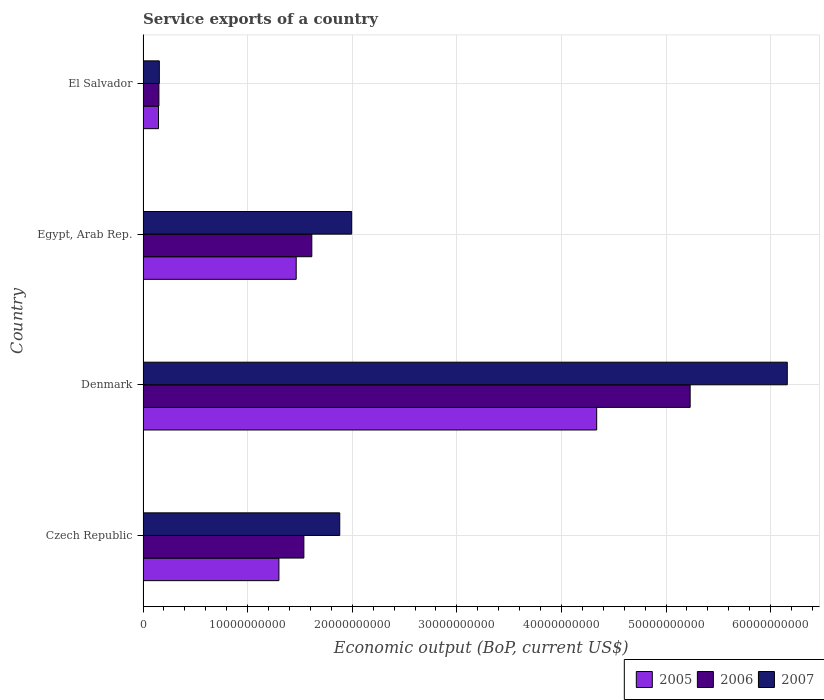How many bars are there on the 4th tick from the top?
Ensure brevity in your answer.  3. What is the label of the 2nd group of bars from the top?
Give a very brief answer. Egypt, Arab Rep. What is the service exports in 2005 in Denmark?
Offer a terse response. 4.34e+1. Across all countries, what is the maximum service exports in 2006?
Provide a short and direct response. 5.23e+1. Across all countries, what is the minimum service exports in 2006?
Provide a succinct answer. 1.52e+09. In which country was the service exports in 2005 minimum?
Your response must be concise. El Salvador. What is the total service exports in 2006 in the graph?
Your answer should be very brief. 8.53e+1. What is the difference between the service exports in 2006 in Denmark and that in Egypt, Arab Rep.?
Keep it short and to the point. 3.62e+1. What is the difference between the service exports in 2007 in Denmark and the service exports in 2005 in Czech Republic?
Your response must be concise. 4.86e+1. What is the average service exports in 2005 per country?
Give a very brief answer. 1.81e+1. What is the difference between the service exports in 2006 and service exports in 2007 in Denmark?
Your answer should be very brief. -9.29e+09. What is the ratio of the service exports in 2005 in Czech Republic to that in Egypt, Arab Rep.?
Your answer should be compact. 0.89. Is the difference between the service exports in 2006 in Denmark and El Salvador greater than the difference between the service exports in 2007 in Denmark and El Salvador?
Give a very brief answer. No. What is the difference between the highest and the second highest service exports in 2006?
Make the answer very short. 3.62e+1. What is the difference between the highest and the lowest service exports in 2005?
Provide a succinct answer. 4.19e+1. In how many countries, is the service exports in 2006 greater than the average service exports in 2006 taken over all countries?
Give a very brief answer. 1. Is the sum of the service exports in 2006 in Denmark and El Salvador greater than the maximum service exports in 2005 across all countries?
Your answer should be compact. Yes. What does the 2nd bar from the top in Egypt, Arab Rep. represents?
Offer a terse response. 2006. What does the 1st bar from the bottom in El Salvador represents?
Make the answer very short. 2005. Are the values on the major ticks of X-axis written in scientific E-notation?
Your answer should be compact. No. Does the graph contain grids?
Ensure brevity in your answer.  Yes. What is the title of the graph?
Your response must be concise. Service exports of a country. What is the label or title of the X-axis?
Your answer should be very brief. Economic output (BoP, current US$). What is the Economic output (BoP, current US$) of 2005 in Czech Republic?
Make the answer very short. 1.30e+1. What is the Economic output (BoP, current US$) in 2006 in Czech Republic?
Offer a very short reply. 1.54e+1. What is the Economic output (BoP, current US$) in 2007 in Czech Republic?
Your answer should be compact. 1.88e+1. What is the Economic output (BoP, current US$) of 2005 in Denmark?
Offer a very short reply. 4.34e+1. What is the Economic output (BoP, current US$) of 2006 in Denmark?
Your answer should be very brief. 5.23e+1. What is the Economic output (BoP, current US$) of 2007 in Denmark?
Provide a succinct answer. 6.16e+1. What is the Economic output (BoP, current US$) in 2005 in Egypt, Arab Rep.?
Offer a very short reply. 1.46e+1. What is the Economic output (BoP, current US$) in 2006 in Egypt, Arab Rep.?
Keep it short and to the point. 1.61e+1. What is the Economic output (BoP, current US$) in 2007 in Egypt, Arab Rep.?
Your answer should be very brief. 1.99e+1. What is the Economic output (BoP, current US$) of 2005 in El Salvador?
Provide a short and direct response. 1.48e+09. What is the Economic output (BoP, current US$) in 2006 in El Salvador?
Offer a terse response. 1.52e+09. What is the Economic output (BoP, current US$) of 2007 in El Salvador?
Make the answer very short. 1.56e+09. Across all countries, what is the maximum Economic output (BoP, current US$) of 2005?
Provide a succinct answer. 4.34e+1. Across all countries, what is the maximum Economic output (BoP, current US$) in 2006?
Keep it short and to the point. 5.23e+1. Across all countries, what is the maximum Economic output (BoP, current US$) in 2007?
Offer a terse response. 6.16e+1. Across all countries, what is the minimum Economic output (BoP, current US$) of 2005?
Provide a succinct answer. 1.48e+09. Across all countries, what is the minimum Economic output (BoP, current US$) in 2006?
Your response must be concise. 1.52e+09. Across all countries, what is the minimum Economic output (BoP, current US$) in 2007?
Offer a very short reply. 1.56e+09. What is the total Economic output (BoP, current US$) of 2005 in the graph?
Your response must be concise. 7.25e+1. What is the total Economic output (BoP, current US$) of 2006 in the graph?
Offer a very short reply. 8.53e+1. What is the total Economic output (BoP, current US$) of 2007 in the graph?
Make the answer very short. 1.02e+11. What is the difference between the Economic output (BoP, current US$) of 2005 in Czech Republic and that in Denmark?
Ensure brevity in your answer.  -3.04e+1. What is the difference between the Economic output (BoP, current US$) in 2006 in Czech Republic and that in Denmark?
Provide a short and direct response. -3.69e+1. What is the difference between the Economic output (BoP, current US$) in 2007 in Czech Republic and that in Denmark?
Provide a short and direct response. -4.28e+1. What is the difference between the Economic output (BoP, current US$) of 2005 in Czech Republic and that in Egypt, Arab Rep.?
Keep it short and to the point. -1.65e+09. What is the difference between the Economic output (BoP, current US$) of 2006 in Czech Republic and that in Egypt, Arab Rep.?
Offer a terse response. -7.59e+08. What is the difference between the Economic output (BoP, current US$) of 2007 in Czech Republic and that in Egypt, Arab Rep.?
Your response must be concise. -1.14e+09. What is the difference between the Economic output (BoP, current US$) in 2005 in Czech Republic and that in El Salvador?
Make the answer very short. 1.15e+1. What is the difference between the Economic output (BoP, current US$) of 2006 in Czech Republic and that in El Salvador?
Make the answer very short. 1.39e+1. What is the difference between the Economic output (BoP, current US$) of 2007 in Czech Republic and that in El Salvador?
Keep it short and to the point. 1.72e+1. What is the difference between the Economic output (BoP, current US$) of 2005 in Denmark and that in Egypt, Arab Rep.?
Your answer should be compact. 2.87e+1. What is the difference between the Economic output (BoP, current US$) of 2006 in Denmark and that in Egypt, Arab Rep.?
Your answer should be compact. 3.62e+1. What is the difference between the Economic output (BoP, current US$) of 2007 in Denmark and that in Egypt, Arab Rep.?
Make the answer very short. 4.17e+1. What is the difference between the Economic output (BoP, current US$) in 2005 in Denmark and that in El Salvador?
Your response must be concise. 4.19e+1. What is the difference between the Economic output (BoP, current US$) in 2006 in Denmark and that in El Salvador?
Ensure brevity in your answer.  5.08e+1. What is the difference between the Economic output (BoP, current US$) of 2007 in Denmark and that in El Salvador?
Your answer should be compact. 6.00e+1. What is the difference between the Economic output (BoP, current US$) of 2005 in Egypt, Arab Rep. and that in El Salvador?
Your answer should be very brief. 1.32e+1. What is the difference between the Economic output (BoP, current US$) of 2006 in Egypt, Arab Rep. and that in El Salvador?
Offer a very short reply. 1.46e+1. What is the difference between the Economic output (BoP, current US$) of 2007 in Egypt, Arab Rep. and that in El Salvador?
Your answer should be compact. 1.84e+1. What is the difference between the Economic output (BoP, current US$) of 2005 in Czech Republic and the Economic output (BoP, current US$) of 2006 in Denmark?
Offer a very short reply. -3.93e+1. What is the difference between the Economic output (BoP, current US$) of 2005 in Czech Republic and the Economic output (BoP, current US$) of 2007 in Denmark?
Provide a succinct answer. -4.86e+1. What is the difference between the Economic output (BoP, current US$) of 2006 in Czech Republic and the Economic output (BoP, current US$) of 2007 in Denmark?
Offer a terse response. -4.62e+1. What is the difference between the Economic output (BoP, current US$) of 2005 in Czech Republic and the Economic output (BoP, current US$) of 2006 in Egypt, Arab Rep.?
Ensure brevity in your answer.  -3.14e+09. What is the difference between the Economic output (BoP, current US$) of 2005 in Czech Republic and the Economic output (BoP, current US$) of 2007 in Egypt, Arab Rep.?
Keep it short and to the point. -6.95e+09. What is the difference between the Economic output (BoP, current US$) in 2006 in Czech Republic and the Economic output (BoP, current US$) in 2007 in Egypt, Arab Rep.?
Give a very brief answer. -4.57e+09. What is the difference between the Economic output (BoP, current US$) of 2005 in Czech Republic and the Economic output (BoP, current US$) of 2006 in El Salvador?
Offer a very short reply. 1.15e+1. What is the difference between the Economic output (BoP, current US$) of 2005 in Czech Republic and the Economic output (BoP, current US$) of 2007 in El Salvador?
Your answer should be compact. 1.14e+1. What is the difference between the Economic output (BoP, current US$) of 2006 in Czech Republic and the Economic output (BoP, current US$) of 2007 in El Salvador?
Give a very brief answer. 1.38e+1. What is the difference between the Economic output (BoP, current US$) in 2005 in Denmark and the Economic output (BoP, current US$) in 2006 in Egypt, Arab Rep.?
Provide a short and direct response. 2.72e+1. What is the difference between the Economic output (BoP, current US$) of 2005 in Denmark and the Economic output (BoP, current US$) of 2007 in Egypt, Arab Rep.?
Your answer should be compact. 2.34e+1. What is the difference between the Economic output (BoP, current US$) in 2006 in Denmark and the Economic output (BoP, current US$) in 2007 in Egypt, Arab Rep.?
Keep it short and to the point. 3.24e+1. What is the difference between the Economic output (BoP, current US$) of 2005 in Denmark and the Economic output (BoP, current US$) of 2006 in El Salvador?
Offer a terse response. 4.19e+1. What is the difference between the Economic output (BoP, current US$) in 2005 in Denmark and the Economic output (BoP, current US$) in 2007 in El Salvador?
Your answer should be very brief. 4.18e+1. What is the difference between the Economic output (BoP, current US$) of 2006 in Denmark and the Economic output (BoP, current US$) of 2007 in El Salvador?
Your answer should be very brief. 5.08e+1. What is the difference between the Economic output (BoP, current US$) of 2005 in Egypt, Arab Rep. and the Economic output (BoP, current US$) of 2006 in El Salvador?
Your answer should be very brief. 1.31e+1. What is the difference between the Economic output (BoP, current US$) of 2005 in Egypt, Arab Rep. and the Economic output (BoP, current US$) of 2007 in El Salvador?
Offer a very short reply. 1.31e+1. What is the difference between the Economic output (BoP, current US$) of 2006 in Egypt, Arab Rep. and the Economic output (BoP, current US$) of 2007 in El Salvador?
Ensure brevity in your answer.  1.46e+1. What is the average Economic output (BoP, current US$) in 2005 per country?
Offer a very short reply. 1.81e+1. What is the average Economic output (BoP, current US$) in 2006 per country?
Your answer should be compact. 2.13e+1. What is the average Economic output (BoP, current US$) in 2007 per country?
Your response must be concise. 2.55e+1. What is the difference between the Economic output (BoP, current US$) in 2005 and Economic output (BoP, current US$) in 2006 in Czech Republic?
Offer a very short reply. -2.39e+09. What is the difference between the Economic output (BoP, current US$) in 2005 and Economic output (BoP, current US$) in 2007 in Czech Republic?
Provide a succinct answer. -5.82e+09. What is the difference between the Economic output (BoP, current US$) in 2006 and Economic output (BoP, current US$) in 2007 in Czech Republic?
Ensure brevity in your answer.  -3.43e+09. What is the difference between the Economic output (BoP, current US$) in 2005 and Economic output (BoP, current US$) in 2006 in Denmark?
Make the answer very short. -8.94e+09. What is the difference between the Economic output (BoP, current US$) in 2005 and Economic output (BoP, current US$) in 2007 in Denmark?
Your answer should be very brief. -1.82e+1. What is the difference between the Economic output (BoP, current US$) in 2006 and Economic output (BoP, current US$) in 2007 in Denmark?
Your answer should be very brief. -9.29e+09. What is the difference between the Economic output (BoP, current US$) of 2005 and Economic output (BoP, current US$) of 2006 in Egypt, Arab Rep.?
Offer a terse response. -1.49e+09. What is the difference between the Economic output (BoP, current US$) in 2005 and Economic output (BoP, current US$) in 2007 in Egypt, Arab Rep.?
Ensure brevity in your answer.  -5.30e+09. What is the difference between the Economic output (BoP, current US$) of 2006 and Economic output (BoP, current US$) of 2007 in Egypt, Arab Rep.?
Give a very brief answer. -3.81e+09. What is the difference between the Economic output (BoP, current US$) in 2005 and Economic output (BoP, current US$) in 2006 in El Salvador?
Offer a very short reply. -3.79e+07. What is the difference between the Economic output (BoP, current US$) in 2005 and Economic output (BoP, current US$) in 2007 in El Salvador?
Provide a short and direct response. -7.76e+07. What is the difference between the Economic output (BoP, current US$) of 2006 and Economic output (BoP, current US$) of 2007 in El Salvador?
Offer a very short reply. -3.97e+07. What is the ratio of the Economic output (BoP, current US$) in 2005 in Czech Republic to that in Denmark?
Make the answer very short. 0.3. What is the ratio of the Economic output (BoP, current US$) in 2006 in Czech Republic to that in Denmark?
Provide a short and direct response. 0.29. What is the ratio of the Economic output (BoP, current US$) of 2007 in Czech Republic to that in Denmark?
Make the answer very short. 0.31. What is the ratio of the Economic output (BoP, current US$) in 2005 in Czech Republic to that in Egypt, Arab Rep.?
Ensure brevity in your answer.  0.89. What is the ratio of the Economic output (BoP, current US$) in 2006 in Czech Republic to that in Egypt, Arab Rep.?
Provide a succinct answer. 0.95. What is the ratio of the Economic output (BoP, current US$) in 2007 in Czech Republic to that in Egypt, Arab Rep.?
Make the answer very short. 0.94. What is the ratio of the Economic output (BoP, current US$) in 2005 in Czech Republic to that in El Salvador?
Your response must be concise. 8.79. What is the ratio of the Economic output (BoP, current US$) of 2006 in Czech Republic to that in El Salvador?
Make the answer very short. 10.14. What is the ratio of the Economic output (BoP, current US$) of 2007 in Czech Republic to that in El Salvador?
Provide a short and direct response. 12.09. What is the ratio of the Economic output (BoP, current US$) of 2005 in Denmark to that in Egypt, Arab Rep.?
Give a very brief answer. 2.96. What is the ratio of the Economic output (BoP, current US$) in 2006 in Denmark to that in Egypt, Arab Rep.?
Your answer should be very brief. 3.24. What is the ratio of the Economic output (BoP, current US$) in 2007 in Denmark to that in Egypt, Arab Rep.?
Offer a terse response. 3.09. What is the ratio of the Economic output (BoP, current US$) in 2005 in Denmark to that in El Salvador?
Provide a short and direct response. 29.34. What is the ratio of the Economic output (BoP, current US$) in 2006 in Denmark to that in El Salvador?
Keep it short and to the point. 34.5. What is the ratio of the Economic output (BoP, current US$) of 2007 in Denmark to that in El Salvador?
Provide a succinct answer. 39.59. What is the ratio of the Economic output (BoP, current US$) in 2005 in Egypt, Arab Rep. to that in El Salvador?
Ensure brevity in your answer.  9.91. What is the ratio of the Economic output (BoP, current US$) in 2006 in Egypt, Arab Rep. to that in El Salvador?
Provide a succinct answer. 10.64. What is the ratio of the Economic output (BoP, current US$) of 2007 in Egypt, Arab Rep. to that in El Salvador?
Your answer should be compact. 12.82. What is the difference between the highest and the second highest Economic output (BoP, current US$) of 2005?
Keep it short and to the point. 2.87e+1. What is the difference between the highest and the second highest Economic output (BoP, current US$) in 2006?
Keep it short and to the point. 3.62e+1. What is the difference between the highest and the second highest Economic output (BoP, current US$) in 2007?
Your answer should be compact. 4.17e+1. What is the difference between the highest and the lowest Economic output (BoP, current US$) in 2005?
Your answer should be compact. 4.19e+1. What is the difference between the highest and the lowest Economic output (BoP, current US$) in 2006?
Provide a short and direct response. 5.08e+1. What is the difference between the highest and the lowest Economic output (BoP, current US$) of 2007?
Make the answer very short. 6.00e+1. 